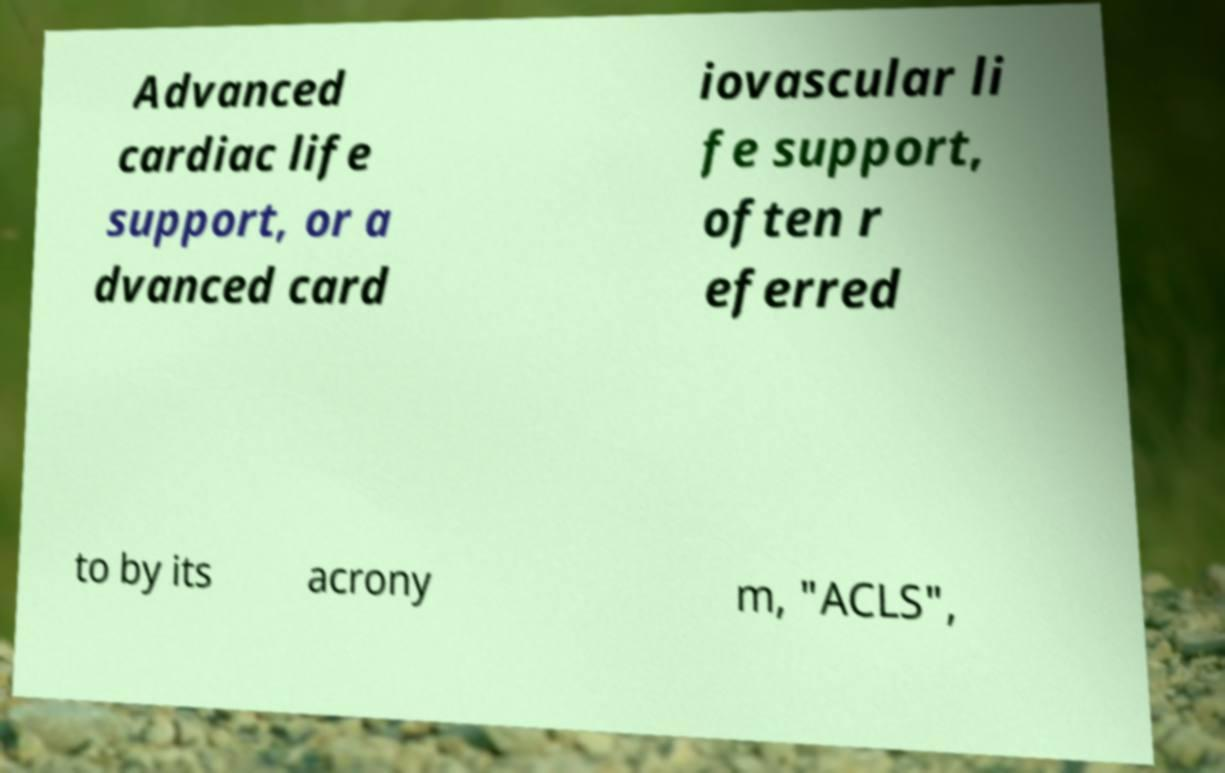Could you assist in decoding the text presented in this image and type it out clearly? Advanced cardiac life support, or a dvanced card iovascular li fe support, often r eferred to by its acrony m, "ACLS", 